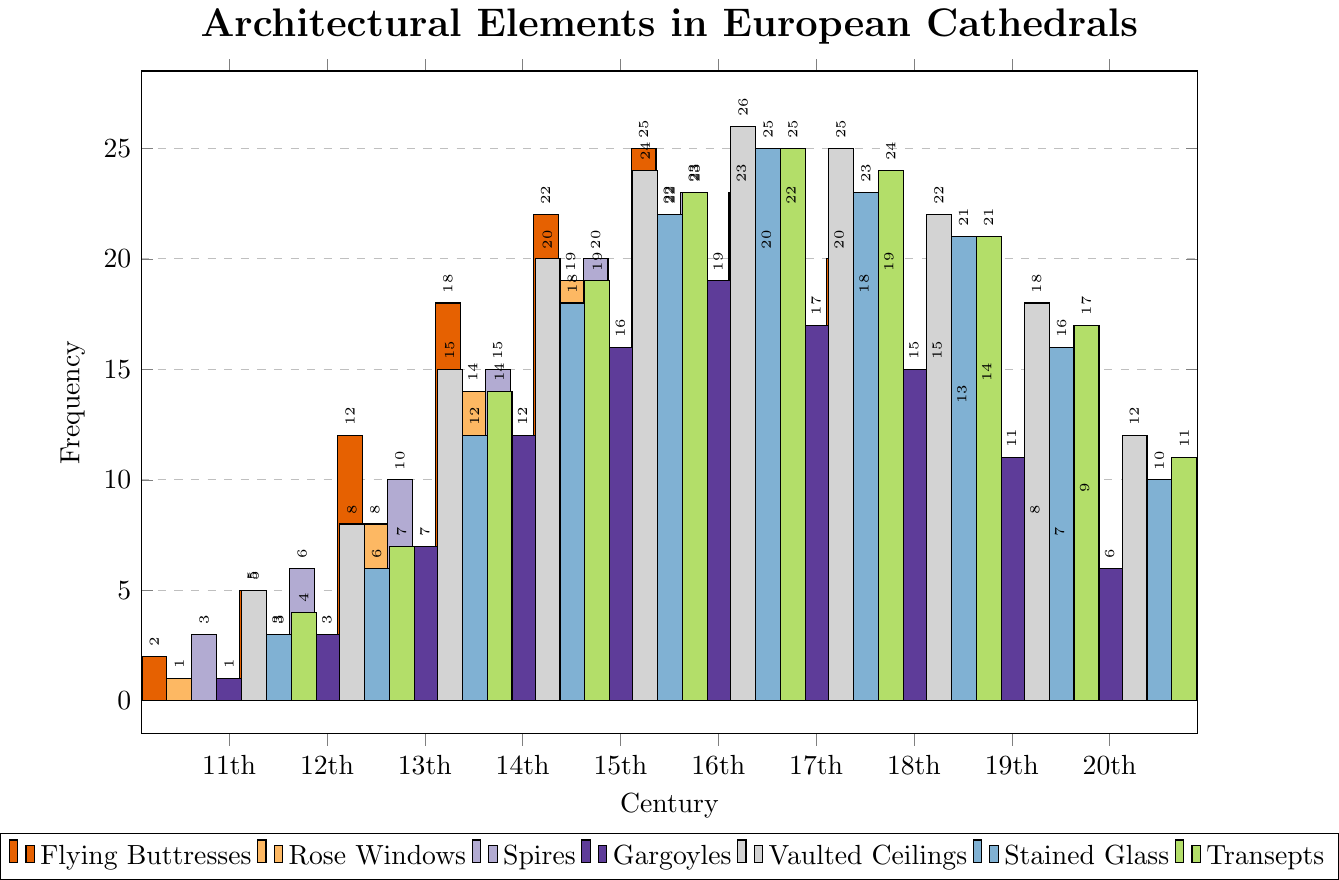What is the frequency of Gargoyles in the 12th century? The bar representing Gargoyles in the 12th century is checked. It reaches up to the value of 3 on the y-axis.
Answer: 3 Which century had the highest frequency of Vaulted Ceilings? The bar heights for Vaulted Ceilings across all centuries are compared. The tallest bar corresponds to the 16th century with a value of 26.
Answer: 16th century What is the combined frequency of Rose Windows and Spires in the 19th century? The height of the bars representing Rose Windows and Spires in the 19th century are summed. Rose Windows frequency is 13, and Spires frequency is 14. Adding these gives 13 + 14 = 27.
Answer: 27 Did the frequency of Flying Buttresses peak in the 16th century? Check the heights of the Flying Buttresses bars across all centuries. The highest peak is in the 16th century with a value of 25.
Answer: Yes What is the difference in the frequency of Transepts between the 11th and 20th centuries? Find the bar heights for Transepts in the 11th and 20th centuries. For the 11th century, it's 4; for the 20th century, it's 11. The difference is calculated as 11 - 4 = 7.
Answer: 7 Which architectural element shows the most significant decline from the 16th to the 20th century? Calculate the difference between 16th and 20th-century frequencies for all elements. Vaulted Ceilings decline from 26 to 12, which is the largest difference (26 - 12 = 14).
Answer: Vaulted Ceilings In which centuries were the frequencies of Stained Glass and Transepts equal? Check where the heights of Stained Glass and Transept bars match across all centuries. Both Stained Glass and Transepts bars in the 16th century have equal heights of 25.
Answer: 16th century What is the average frequency of Flying Buttresses over the centuries? Sum the frequencies of Flying Buttresses for all centuries and divide by the total number of centuries (10). The sum is 2+5+12+18+22+25+23+20+15+8 = 150, average is 150 / 10 = 15.
Answer: 15 Is there a century where the frequency of Spires is greater than the frequency of Stained Glass? Compare the heights of Spires and Stained Glass bars for each century. There is no century where the frequency of Spires is higher than that of Stained Glass.
Answer: No 